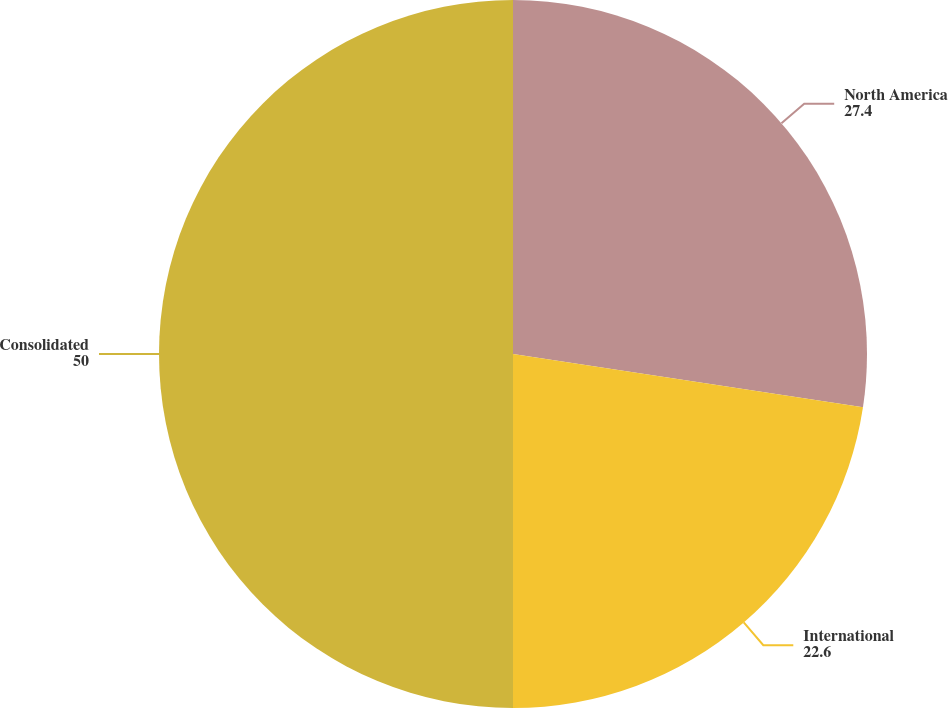Convert chart. <chart><loc_0><loc_0><loc_500><loc_500><pie_chart><fcel>North America<fcel>International<fcel>Consolidated<nl><fcel>27.4%<fcel>22.6%<fcel>50.0%<nl></chart> 